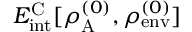Convert formula to latex. <formula><loc_0><loc_0><loc_500><loc_500>E _ { i n t } ^ { C } [ \rho _ { A } ^ { ( 0 ) } , \rho _ { e n v } ^ { ( 0 ) } ]</formula> 